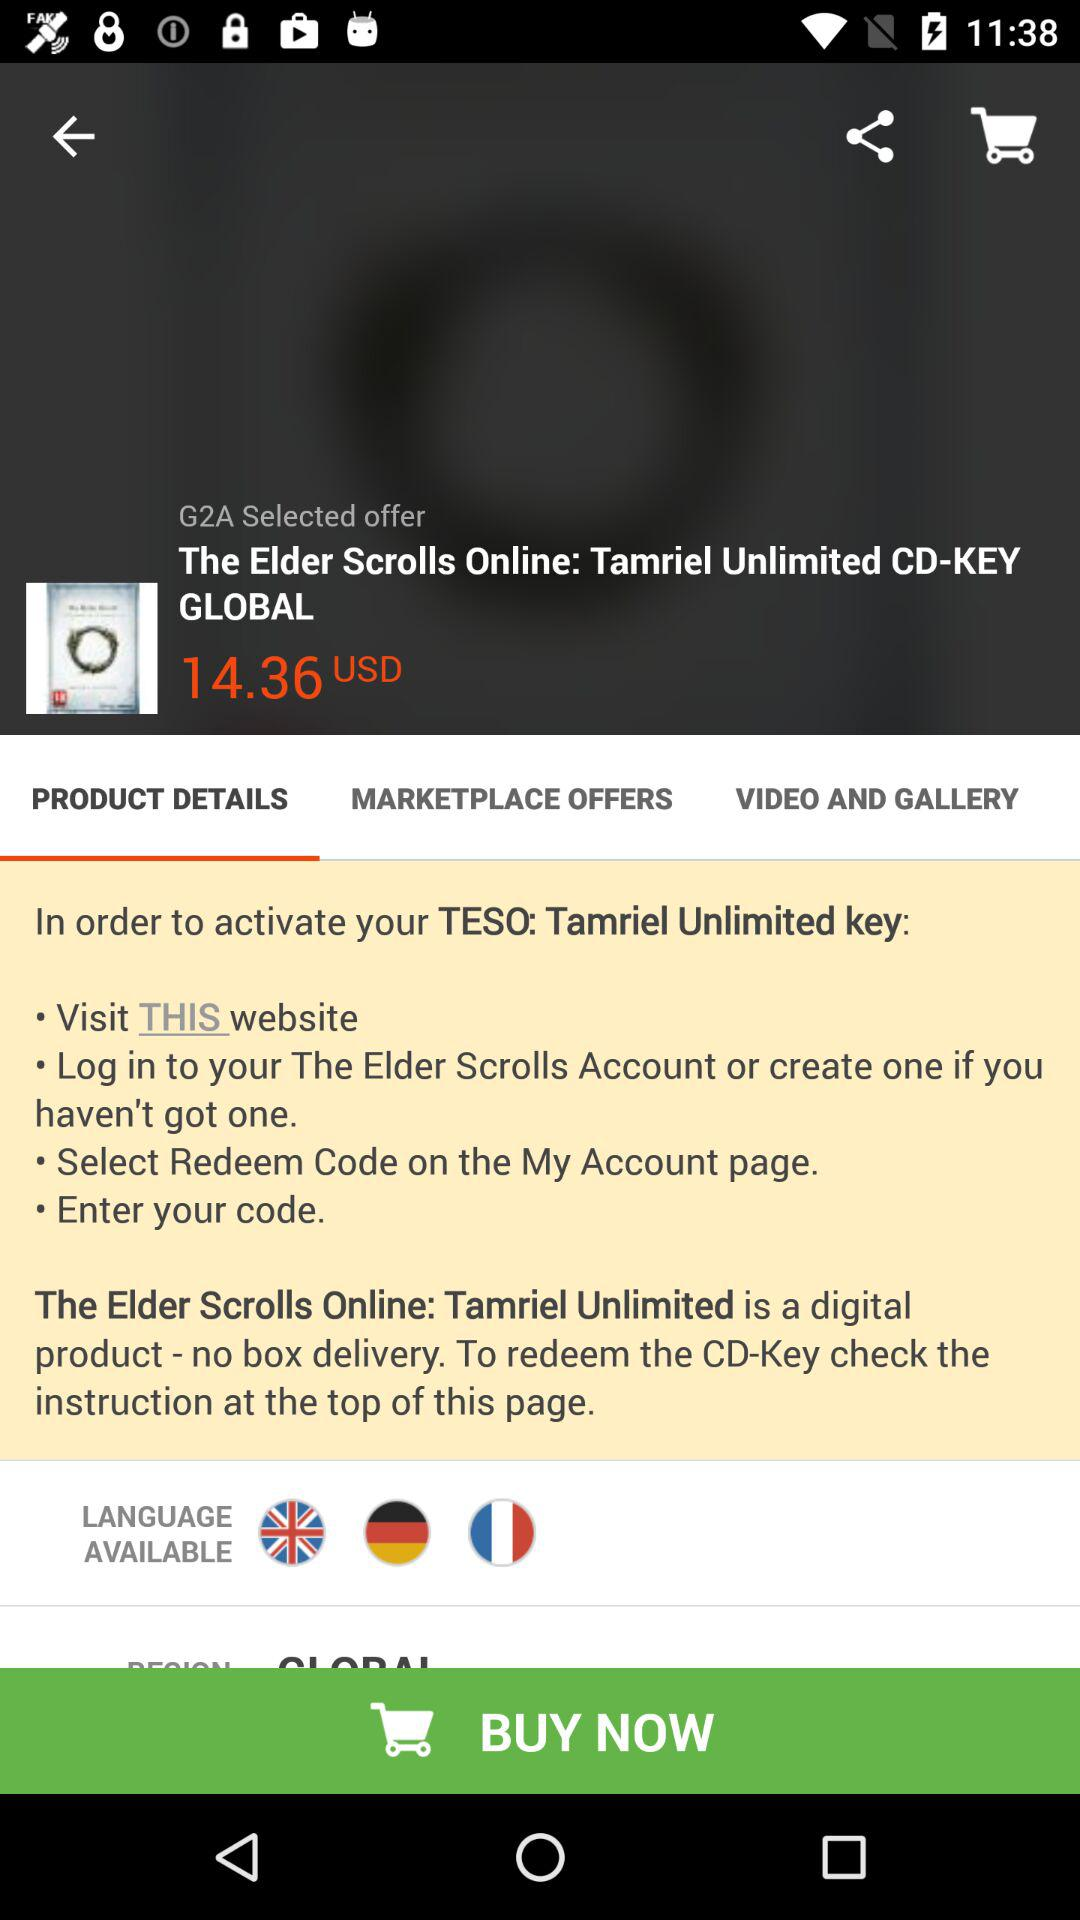How many languages are available for this game?
Answer the question using a single word or phrase. 3 